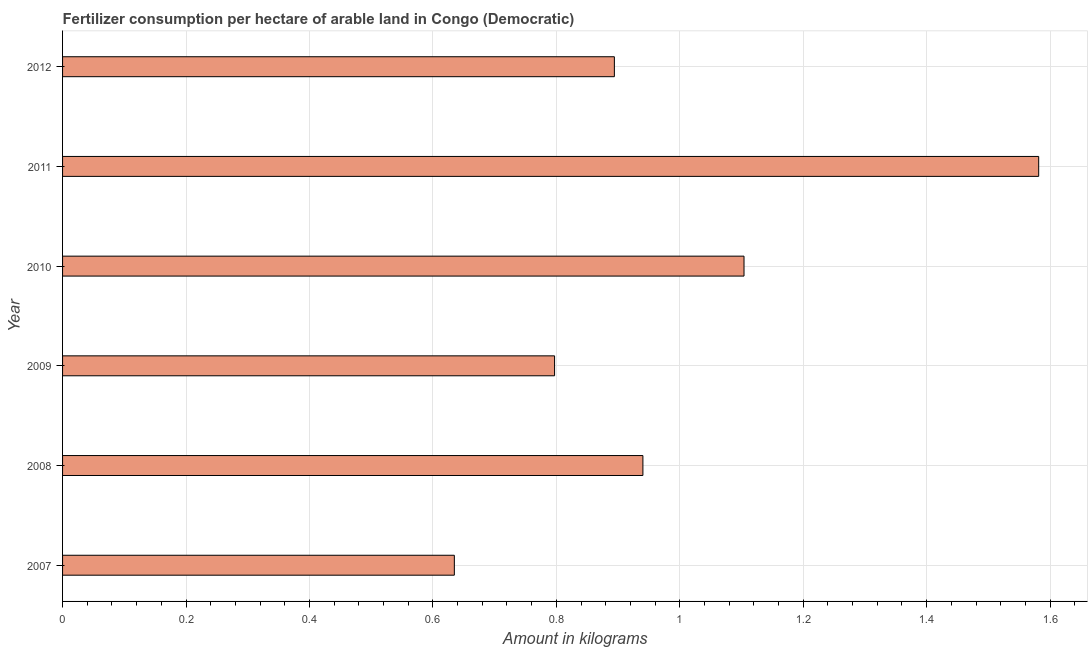Does the graph contain any zero values?
Your response must be concise. No. Does the graph contain grids?
Give a very brief answer. Yes. What is the title of the graph?
Your answer should be very brief. Fertilizer consumption per hectare of arable land in Congo (Democratic) . What is the label or title of the X-axis?
Your answer should be very brief. Amount in kilograms. What is the label or title of the Y-axis?
Ensure brevity in your answer.  Year. What is the amount of fertilizer consumption in 2009?
Offer a terse response. 0.8. Across all years, what is the maximum amount of fertilizer consumption?
Keep it short and to the point. 1.58. Across all years, what is the minimum amount of fertilizer consumption?
Make the answer very short. 0.63. What is the sum of the amount of fertilizer consumption?
Ensure brevity in your answer.  5.95. What is the difference between the amount of fertilizer consumption in 2008 and 2009?
Offer a very short reply. 0.14. What is the average amount of fertilizer consumption per year?
Your response must be concise. 0.99. What is the median amount of fertilizer consumption?
Offer a terse response. 0.92. In how many years, is the amount of fertilizer consumption greater than 0.72 kg?
Your answer should be very brief. 5. What is the ratio of the amount of fertilizer consumption in 2008 to that in 2012?
Your response must be concise. 1.05. What is the difference between the highest and the second highest amount of fertilizer consumption?
Give a very brief answer. 0.48. Is the sum of the amount of fertilizer consumption in 2008 and 2012 greater than the maximum amount of fertilizer consumption across all years?
Offer a very short reply. Yes. Are all the bars in the graph horizontal?
Your response must be concise. Yes. Are the values on the major ticks of X-axis written in scientific E-notation?
Give a very brief answer. No. What is the Amount in kilograms of 2007?
Provide a succinct answer. 0.63. What is the Amount in kilograms in 2008?
Give a very brief answer. 0.94. What is the Amount in kilograms in 2009?
Keep it short and to the point. 0.8. What is the Amount in kilograms in 2010?
Provide a succinct answer. 1.1. What is the Amount in kilograms in 2011?
Your answer should be very brief. 1.58. What is the Amount in kilograms of 2012?
Offer a terse response. 0.89. What is the difference between the Amount in kilograms in 2007 and 2008?
Offer a very short reply. -0.31. What is the difference between the Amount in kilograms in 2007 and 2009?
Your answer should be compact. -0.16. What is the difference between the Amount in kilograms in 2007 and 2010?
Give a very brief answer. -0.47. What is the difference between the Amount in kilograms in 2007 and 2011?
Ensure brevity in your answer.  -0.95. What is the difference between the Amount in kilograms in 2007 and 2012?
Your answer should be compact. -0.26. What is the difference between the Amount in kilograms in 2008 and 2009?
Offer a very short reply. 0.14. What is the difference between the Amount in kilograms in 2008 and 2010?
Your answer should be very brief. -0.16. What is the difference between the Amount in kilograms in 2008 and 2011?
Make the answer very short. -0.64. What is the difference between the Amount in kilograms in 2008 and 2012?
Provide a short and direct response. 0.05. What is the difference between the Amount in kilograms in 2009 and 2010?
Your response must be concise. -0.31. What is the difference between the Amount in kilograms in 2009 and 2011?
Provide a succinct answer. -0.78. What is the difference between the Amount in kilograms in 2009 and 2012?
Keep it short and to the point. -0.1. What is the difference between the Amount in kilograms in 2010 and 2011?
Keep it short and to the point. -0.48. What is the difference between the Amount in kilograms in 2010 and 2012?
Provide a succinct answer. 0.21. What is the difference between the Amount in kilograms in 2011 and 2012?
Give a very brief answer. 0.69. What is the ratio of the Amount in kilograms in 2007 to that in 2008?
Your answer should be compact. 0.68. What is the ratio of the Amount in kilograms in 2007 to that in 2009?
Your answer should be compact. 0.8. What is the ratio of the Amount in kilograms in 2007 to that in 2010?
Your answer should be compact. 0.57. What is the ratio of the Amount in kilograms in 2007 to that in 2011?
Provide a short and direct response. 0.4. What is the ratio of the Amount in kilograms in 2007 to that in 2012?
Your response must be concise. 0.71. What is the ratio of the Amount in kilograms in 2008 to that in 2009?
Provide a succinct answer. 1.18. What is the ratio of the Amount in kilograms in 2008 to that in 2010?
Your answer should be compact. 0.85. What is the ratio of the Amount in kilograms in 2008 to that in 2011?
Keep it short and to the point. 0.59. What is the ratio of the Amount in kilograms in 2008 to that in 2012?
Keep it short and to the point. 1.05. What is the ratio of the Amount in kilograms in 2009 to that in 2010?
Keep it short and to the point. 0.72. What is the ratio of the Amount in kilograms in 2009 to that in 2011?
Ensure brevity in your answer.  0.5. What is the ratio of the Amount in kilograms in 2009 to that in 2012?
Offer a terse response. 0.89. What is the ratio of the Amount in kilograms in 2010 to that in 2011?
Provide a short and direct response. 0.7. What is the ratio of the Amount in kilograms in 2010 to that in 2012?
Ensure brevity in your answer.  1.24. What is the ratio of the Amount in kilograms in 2011 to that in 2012?
Provide a succinct answer. 1.77. 